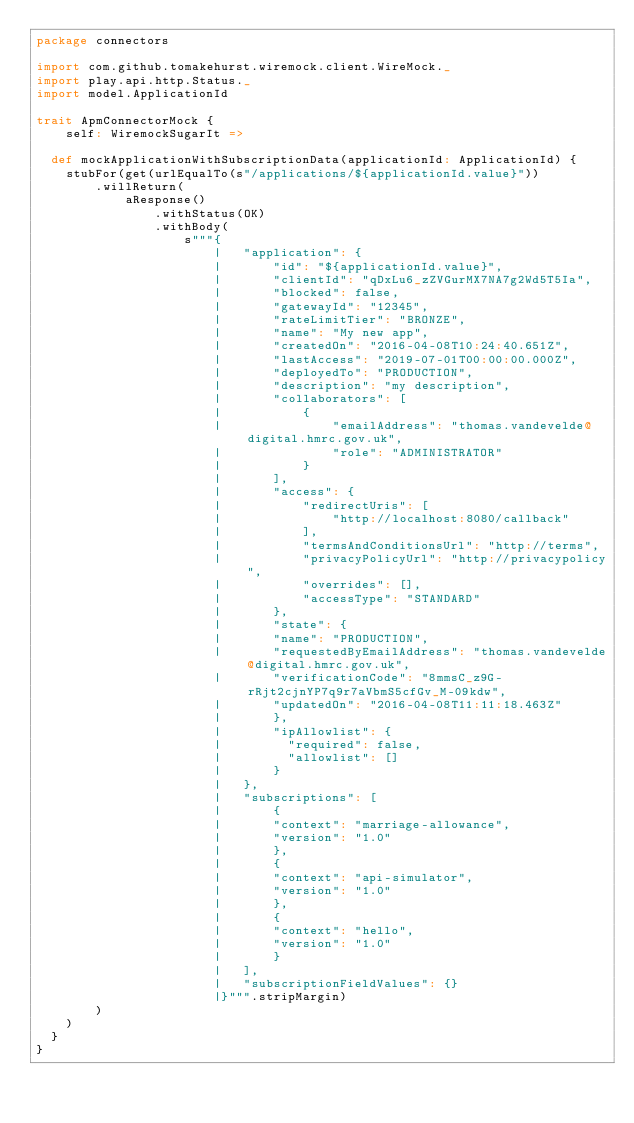Convert code to text. <code><loc_0><loc_0><loc_500><loc_500><_Scala_>package connectors

import com.github.tomakehurst.wiremock.client.WireMock._
import play.api.http.Status._
import model.ApplicationId

trait ApmConnectorMock {
    self: WiremockSugarIt =>

  def mockApplicationWithSubscriptionData(applicationId: ApplicationId) {
    stubFor(get(urlEqualTo(s"/applications/${applicationId.value}"))
        .willReturn(
            aResponse()
                .withStatus(OK)
                .withBody(
                    s"""{
                        |   "application": {
                        |       "id": "${applicationId.value}",
                        |       "clientId": "qDxLu6_zZVGurMX7NA7g2Wd5T5Ia",
                        |       "blocked": false,
                        |       "gatewayId": "12345",
                        |       "rateLimitTier": "BRONZE",
                        |       "name": "My new app",
                        |       "createdOn": "2016-04-08T10:24:40.651Z",
                        |       "lastAccess": "2019-07-01T00:00:00.000Z",
                        |       "deployedTo": "PRODUCTION",
                        |       "description": "my description",
                        |       "collaborators": [
                        |           {
                        |               "emailAddress": "thomas.vandevelde@digital.hmrc.gov.uk",
                        |               "role": "ADMINISTRATOR"
                        |           }
                        |       ],
                        |       "access": {
                        |           "redirectUris": [
                        |               "http://localhost:8080/callback"
                        |           ],
                        |           "termsAndConditionsUrl": "http://terms",
                        |           "privacyPolicyUrl": "http://privacypolicy",
                        |           "overrides": [],
                        |           "accessType": "STANDARD"
                        |       },
                        |       "state": {
                        |       "name": "PRODUCTION",
                        |       "requestedByEmailAddress": "thomas.vandevelde@digital.hmrc.gov.uk",
                        |       "verificationCode": "8mmsC_z9G-rRjt2cjnYP7q9r7aVbmS5cfGv_M-09kdw",
                        |       "updatedOn": "2016-04-08T11:11:18.463Z"
                        |       },
                        |       "ipAllowlist": {
                        |         "required": false,
                        |         "allowlist": []
                        |       }
                        |   },
                        |   "subscriptions": [
                        |       {
                        |       "context": "marriage-allowance",
                        |       "version": "1.0"
                        |       },
                        |       {
                        |       "context": "api-simulator",
                        |       "version": "1.0"
                        |       },
                        |       {
                        |       "context": "hello",
                        |       "version": "1.0"
                        |       }
                        |   ],
                        |   "subscriptionFieldValues": {}
                        |}""".stripMargin)
        )
    )
  }
}
</code> 